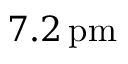Convert formula to latex. <formula><loc_0><loc_0><loc_500><loc_500>7 . 2 \, p m</formula> 